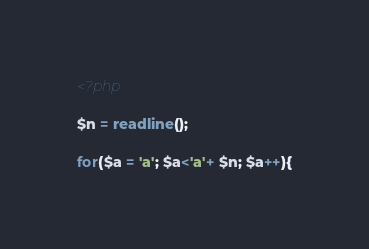<code> <loc_0><loc_0><loc_500><loc_500><_PHP_><?php

$n = readline();

for($a = 'a'; $a<'a'+ $n; $a++){</code> 